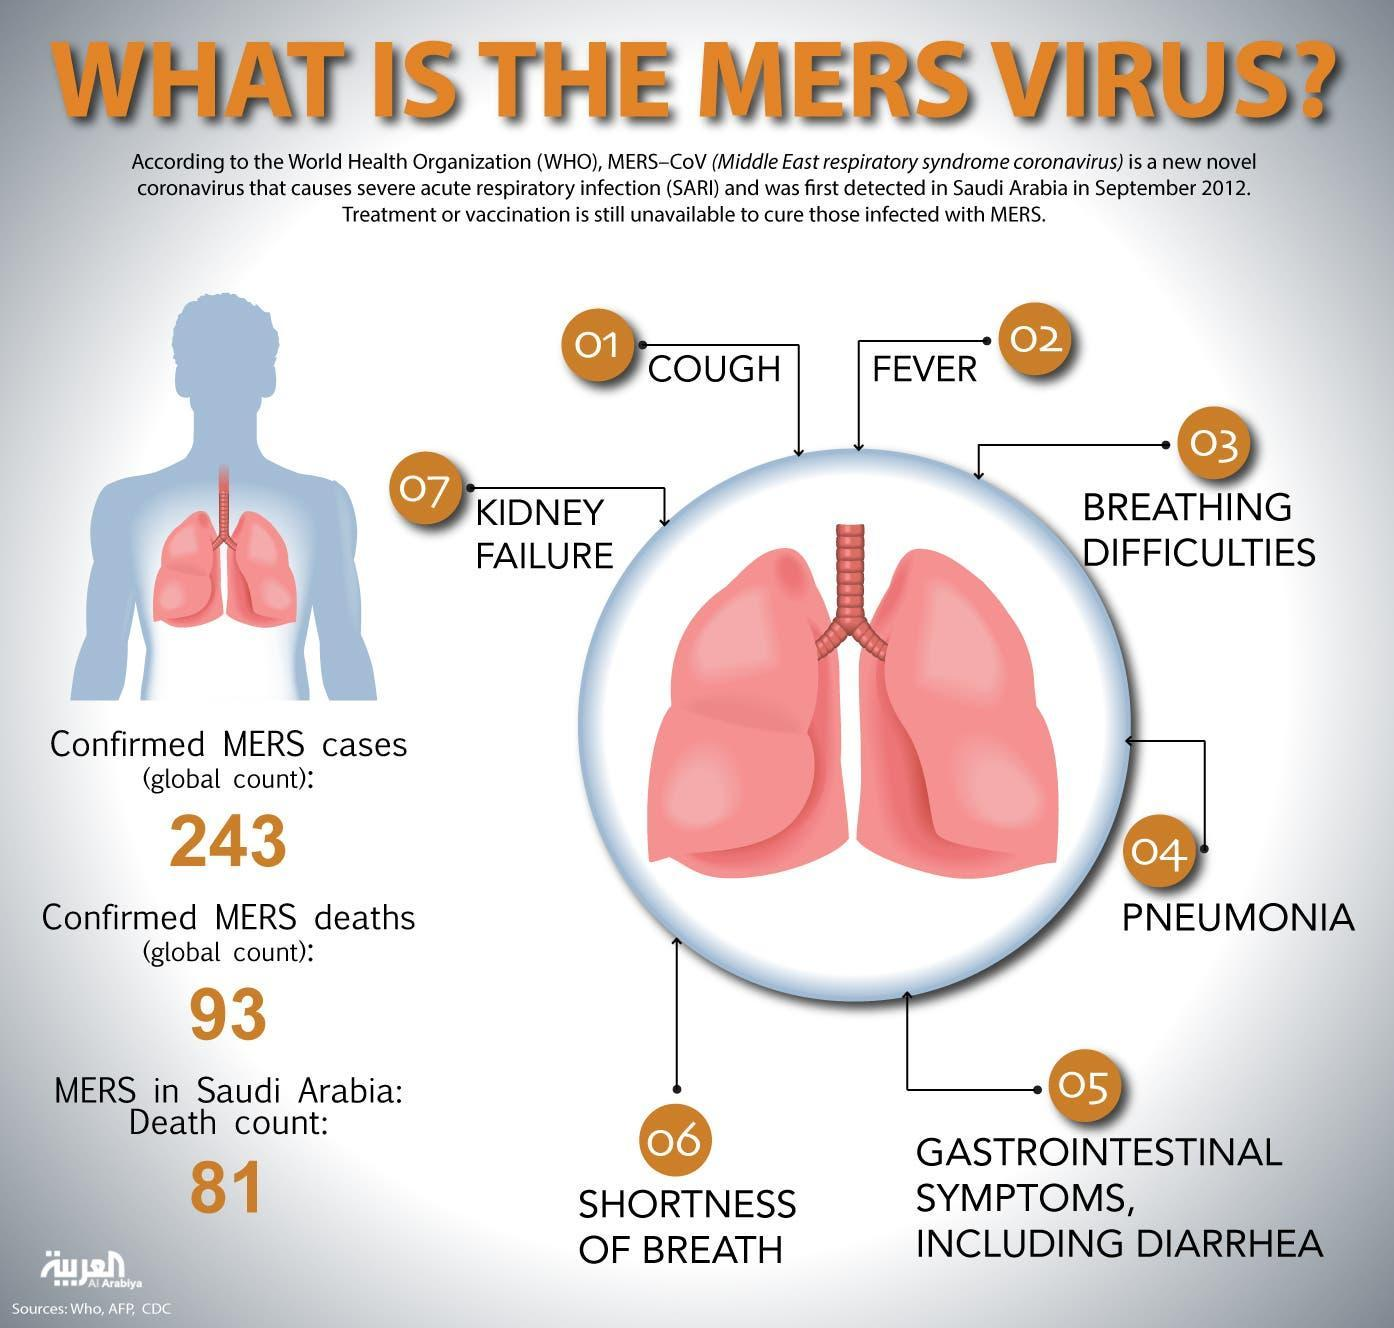What is the difference between confirmed MERS cases and MERS deaths?
Answer the question with a short phrase. 150 What is the number of death count in Saudi Arabia? 81 What is the number of symptoms of the MERS virus? 7 